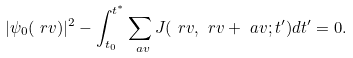Convert formula to latex. <formula><loc_0><loc_0><loc_500><loc_500>| \psi _ { 0 } ( \ r v ) | ^ { 2 } - \int _ { t _ { 0 } } ^ { t ^ { * } } \sum _ { \ a v } J ( \ r v , \ r v + \ a v ; t ^ { \prime } ) d t ^ { \prime } = 0 .</formula> 